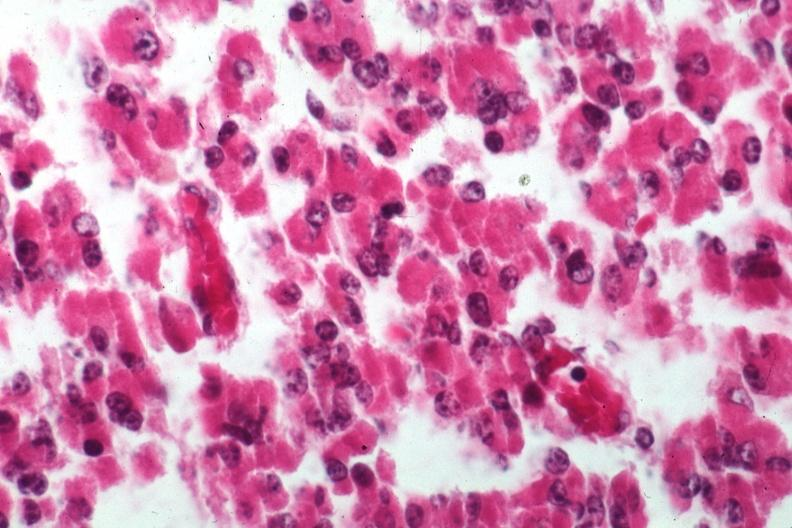does this image show cells of adenoma?
Answer the question using a single word or phrase. Yes 